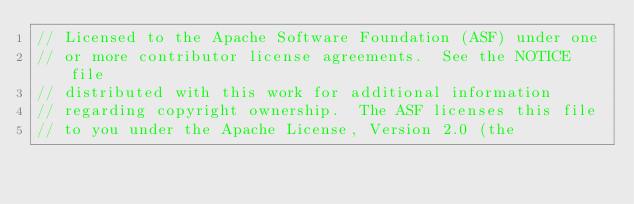<code> <loc_0><loc_0><loc_500><loc_500><_C++_>// Licensed to the Apache Software Foundation (ASF) under one
// or more contributor license agreements.  See the NOTICE file
// distributed with this work for additional information
// regarding copyright ownership.  The ASF licenses this file
// to you under the Apache License, Version 2.0 (the</code> 